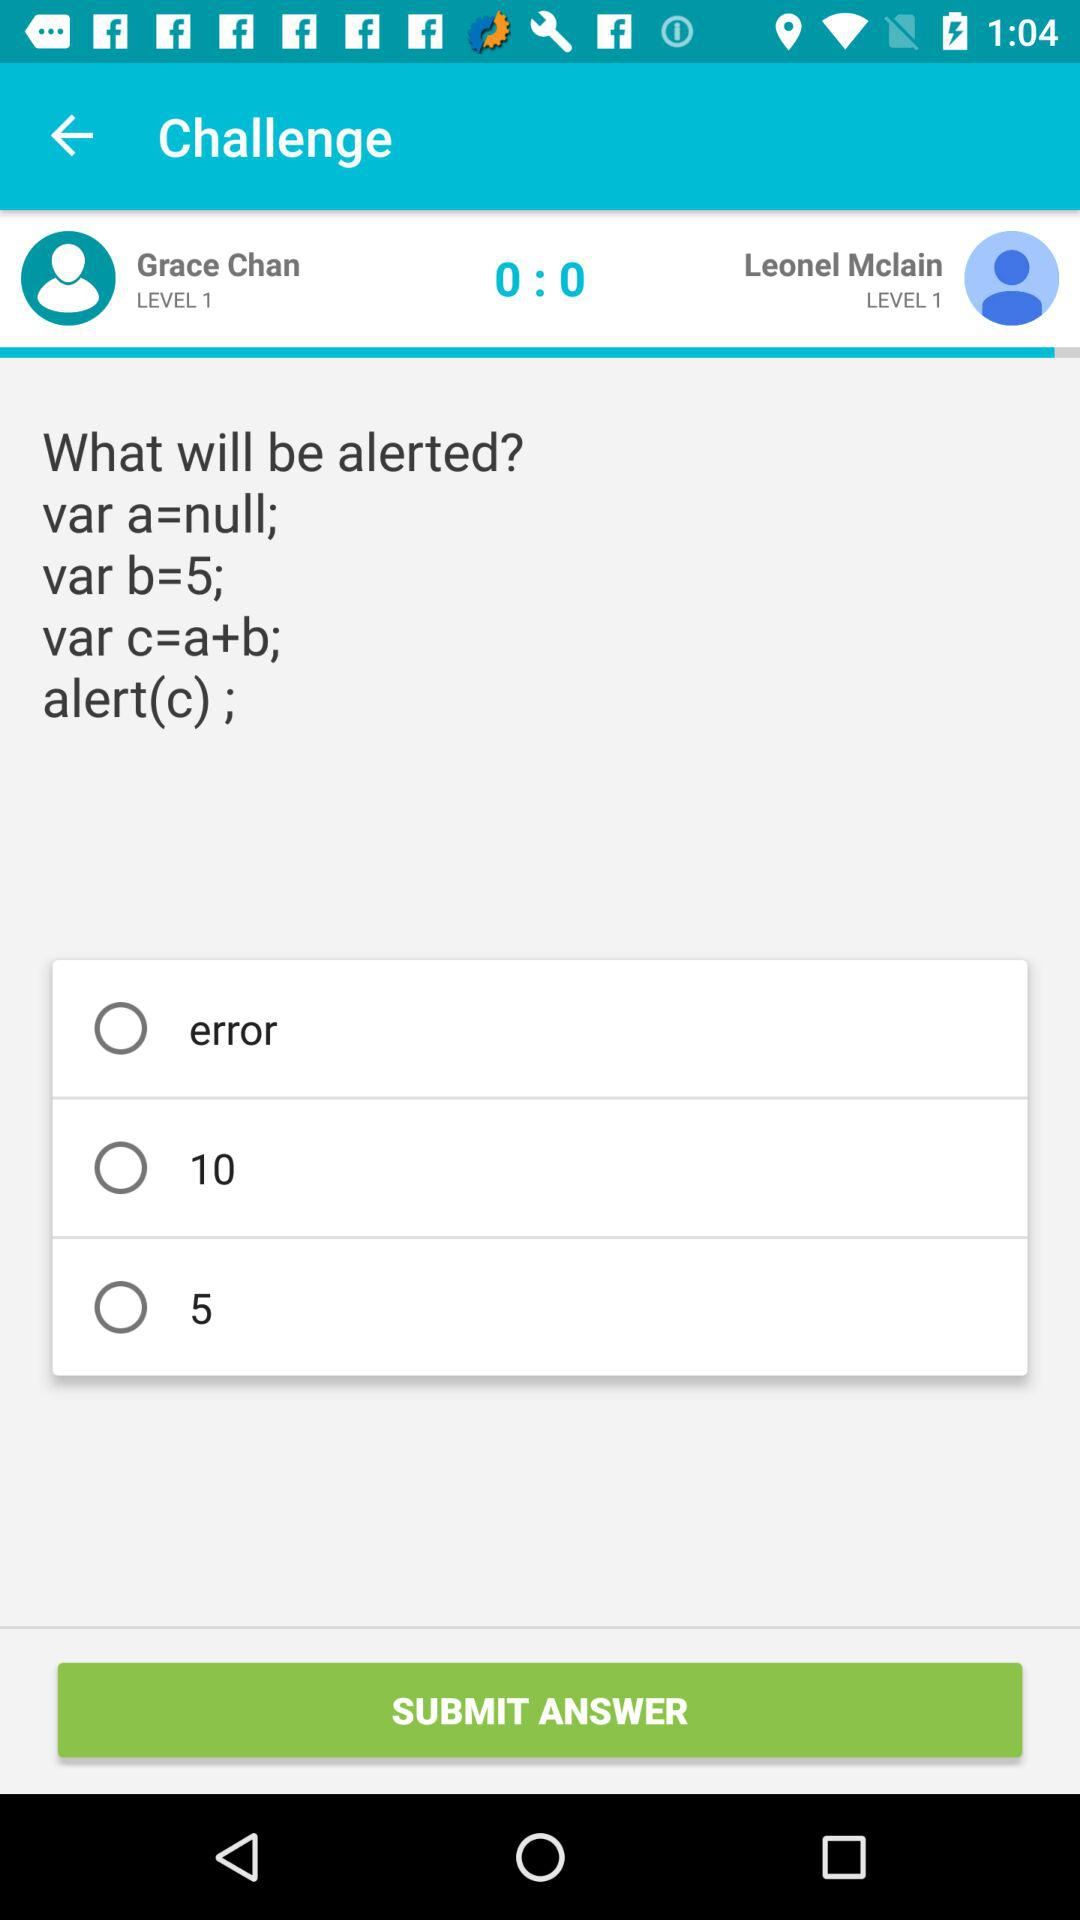What is the value of var b? The value of var b is 5. 